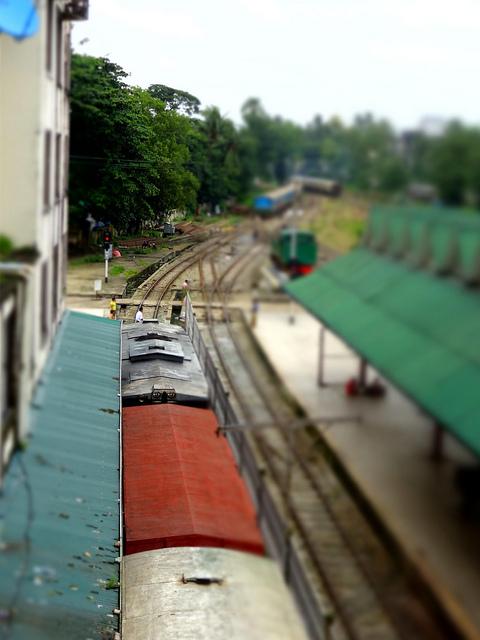Is the photo blurry?
Quick response, please. Yes. Where is the red car?
Quick response, please. Middle. How many train segments are visible?
Be succinct. 3. 